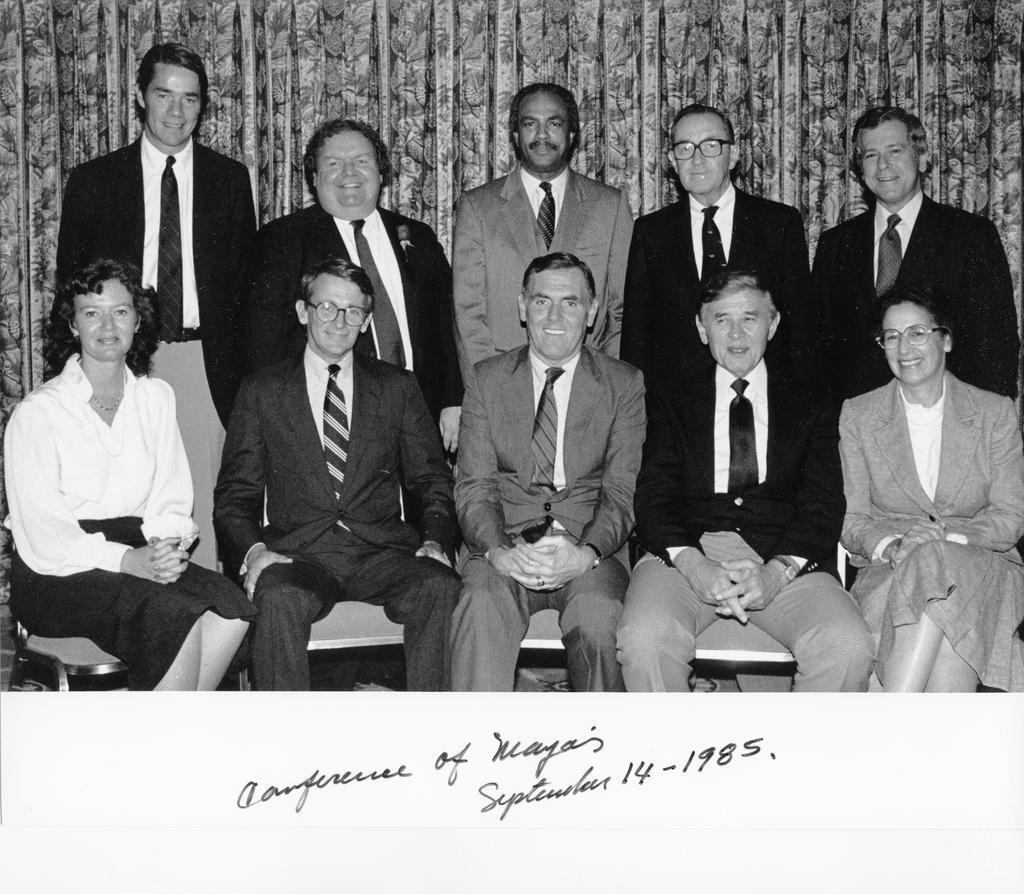How would you summarize this image in a sentence or two? In this image, we can see some people sitting on the chairs and there are some people standing, in the background we can see some curtains. 